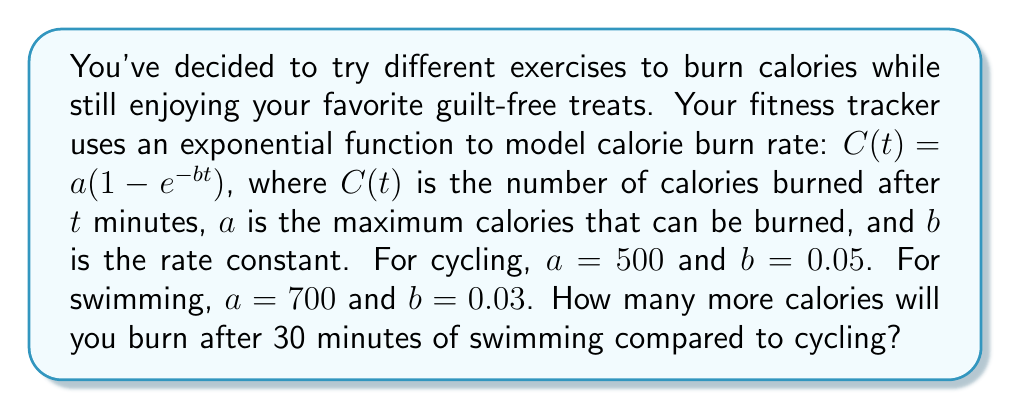Provide a solution to this math problem. Let's approach this step-by-step:

1) For cycling:
   $C_c(t) = 500(1 - e^{-0.05t})$
   After 30 minutes:
   $C_c(30) = 500(1 - e^{-0.05 * 30})$
            $= 500(1 - e^{-1.5})$
            $= 500(1 - 0.2231)$
            $= 500 * 0.7769$
            $= 388.45$ calories

2) For swimming:
   $C_s(t) = 700(1 - e^{-0.03t})$
   After 30 minutes:
   $C_s(30) = 700(1 - e^{-0.03 * 30})$
            $= 700(1 - e^{-0.9})$
            $= 700(1 - 0.4066)$
            $= 700 * 0.5934$
            $= 415.38$ calories

3) Difference in calories burned:
   $415.38 - 388.45 = 26.93$ calories

Therefore, after 30 minutes, swimming will burn about 26.93 more calories than cycling.
Answer: 26.93 calories 